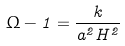Convert formula to latex. <formula><loc_0><loc_0><loc_500><loc_500>\Omega - 1 = \frac { k } { a ^ { 2 } H ^ { 2 } }</formula> 